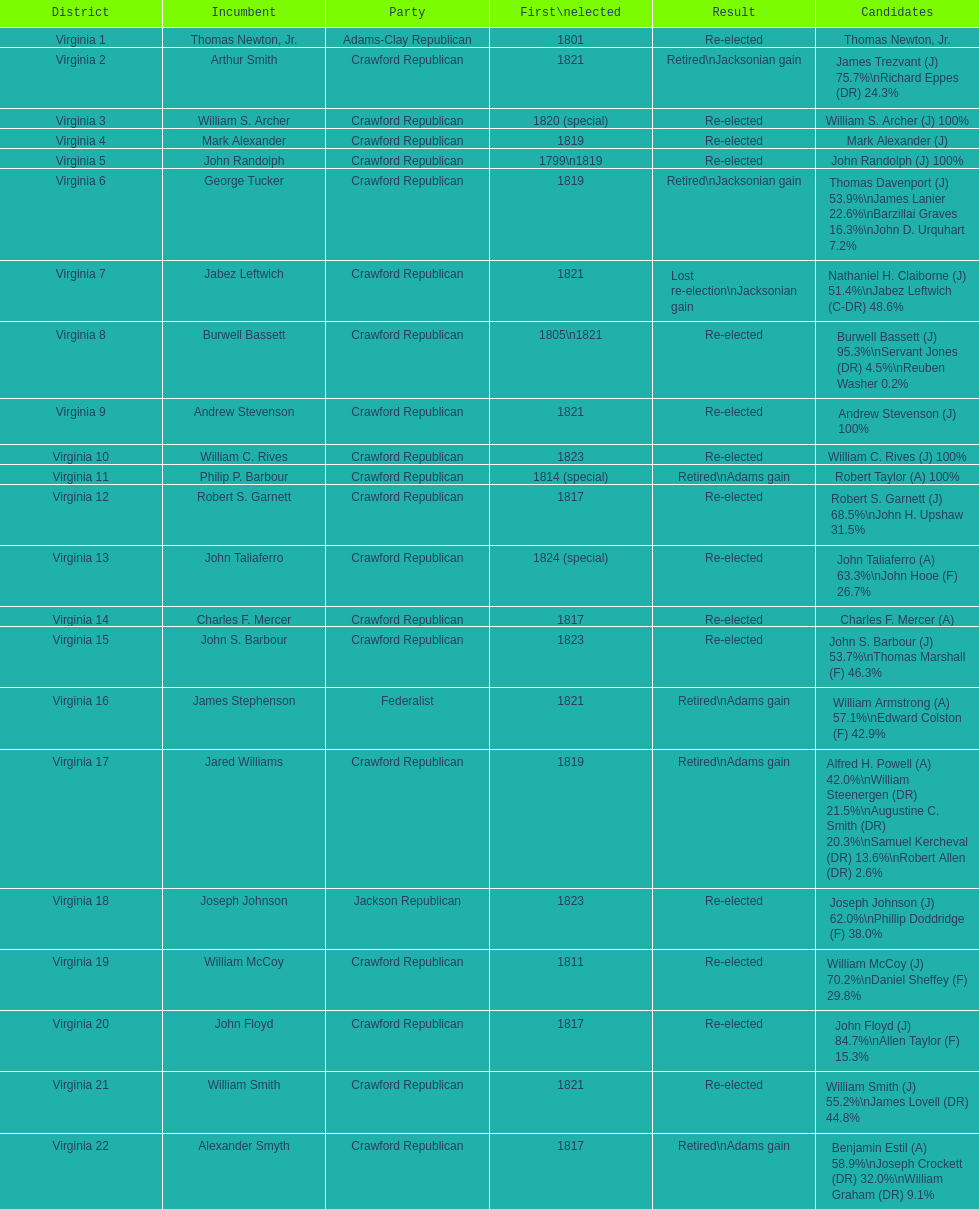How many candidates were there for virginia 17 district? 5. 